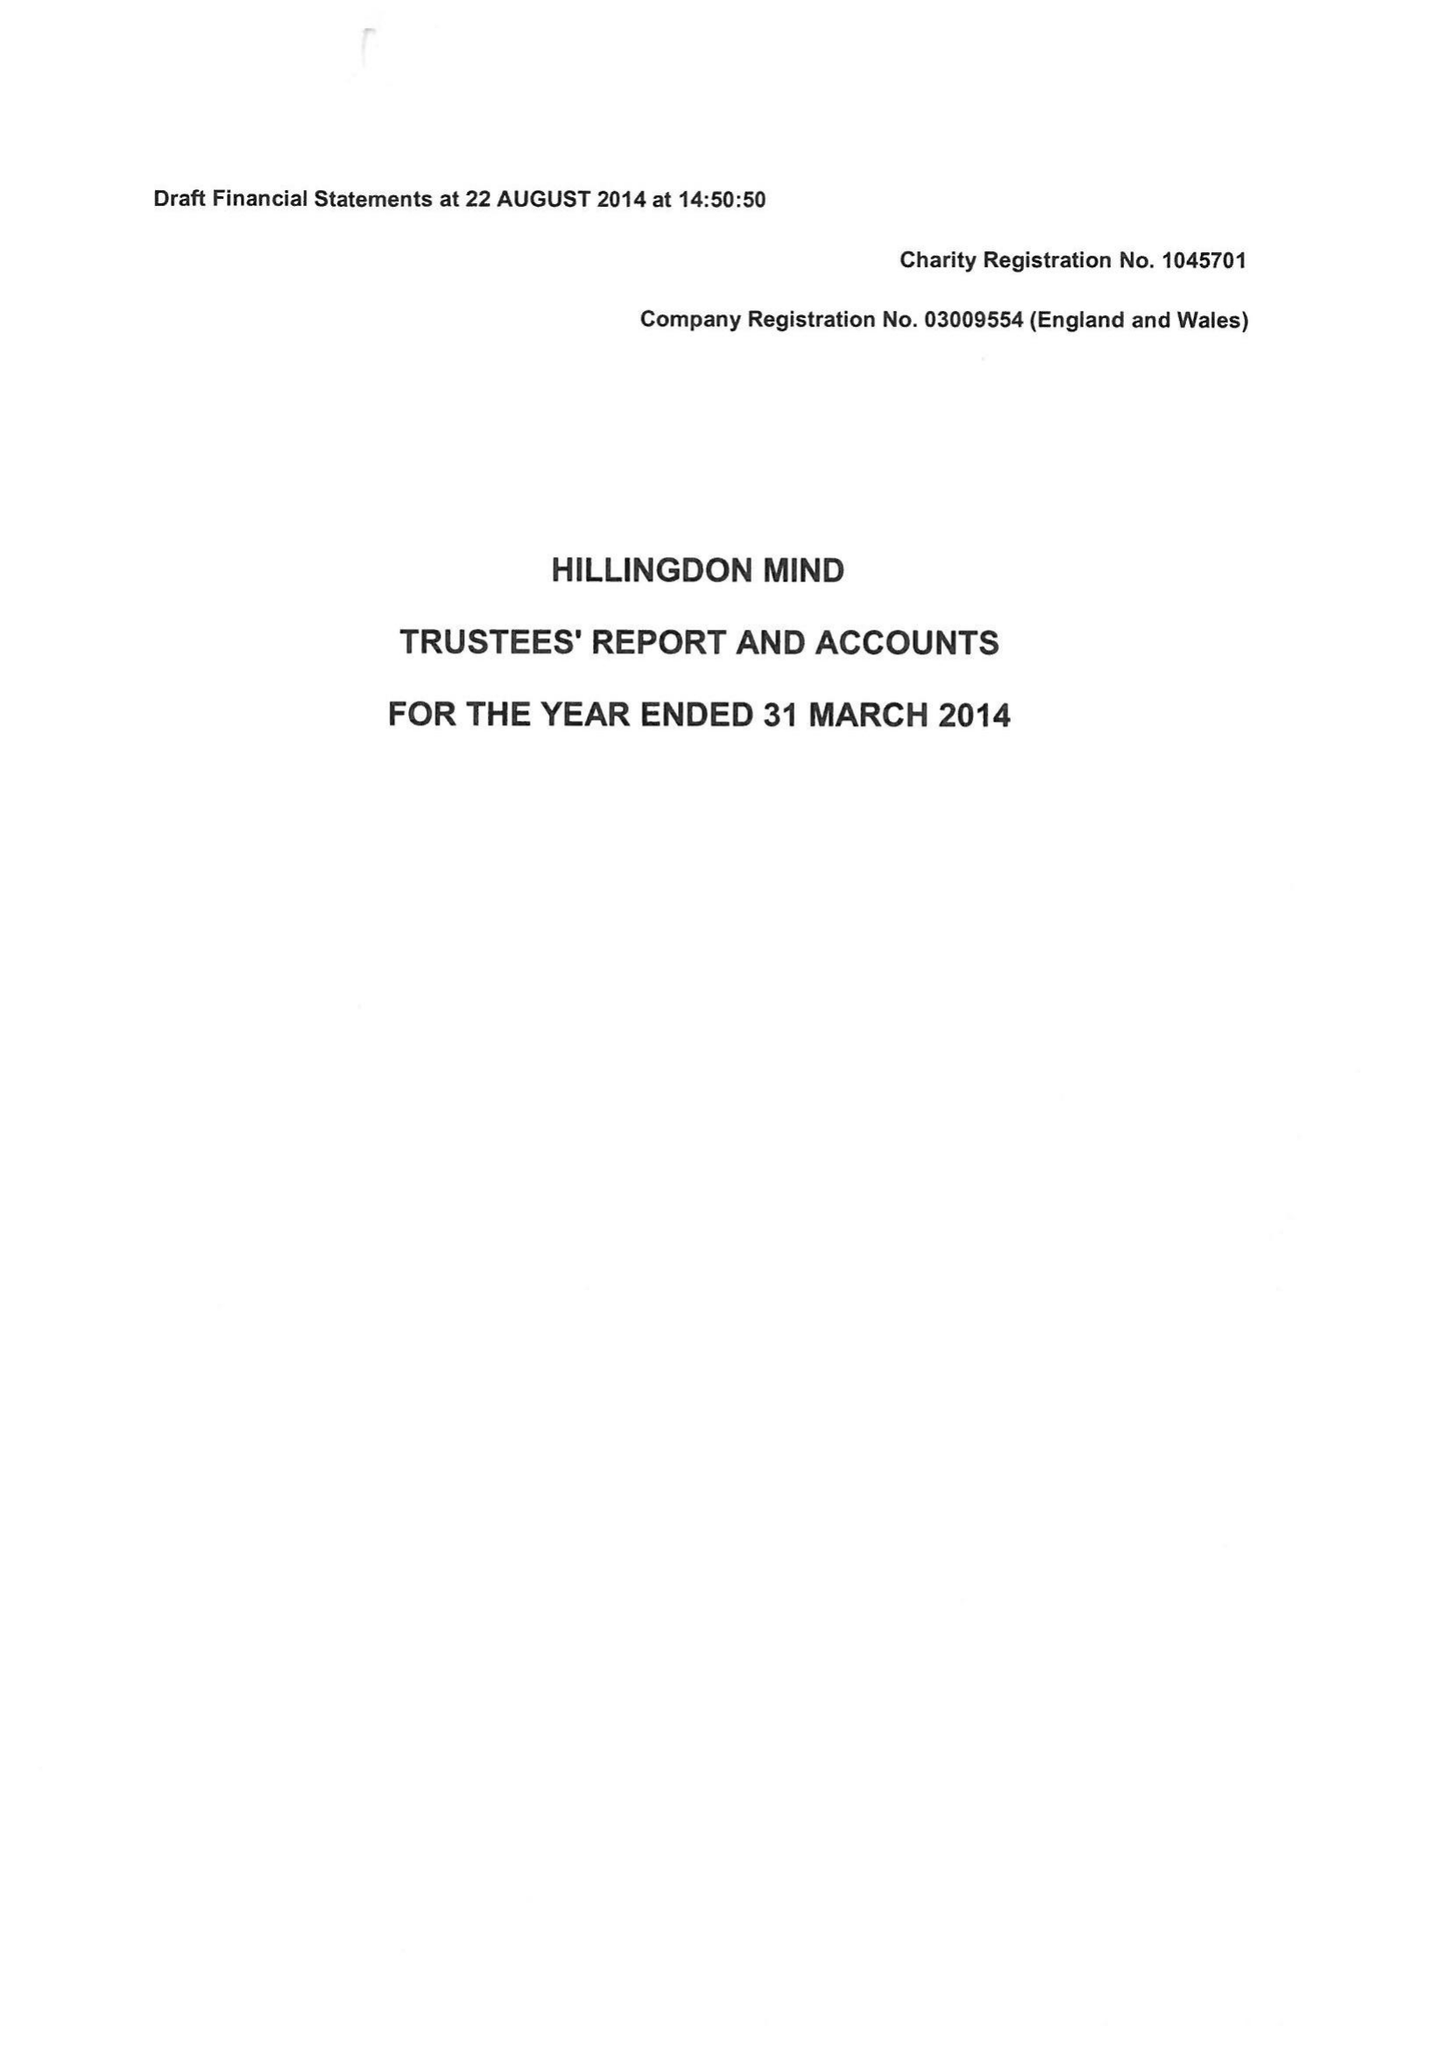What is the value for the spending_annually_in_british_pounds?
Answer the question using a single word or phrase. 444941.00 